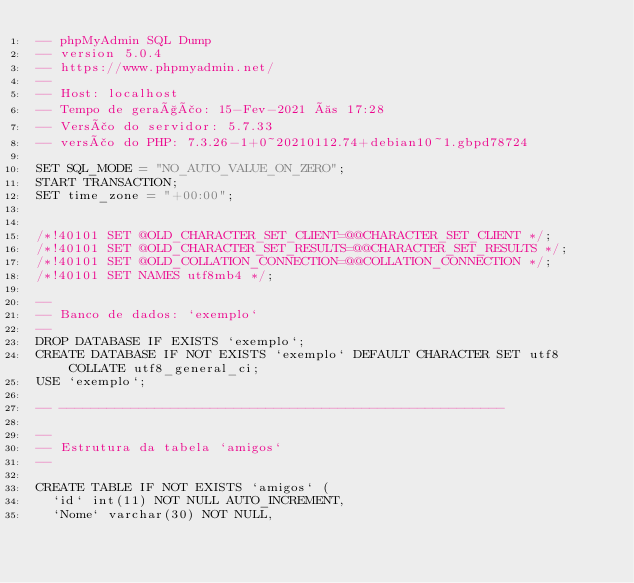<code> <loc_0><loc_0><loc_500><loc_500><_SQL_>-- phpMyAdmin SQL Dump
-- version 5.0.4
-- https://www.phpmyadmin.net/
--
-- Host: localhost
-- Tempo de geração: 15-Fev-2021 às 17:28
-- Versão do servidor: 5.7.33
-- versão do PHP: 7.3.26-1+0~20210112.74+debian10~1.gbpd78724

SET SQL_MODE = "NO_AUTO_VALUE_ON_ZERO";
START TRANSACTION;
SET time_zone = "+00:00";


/*!40101 SET @OLD_CHARACTER_SET_CLIENT=@@CHARACTER_SET_CLIENT */;
/*!40101 SET @OLD_CHARACTER_SET_RESULTS=@@CHARACTER_SET_RESULTS */;
/*!40101 SET @OLD_COLLATION_CONNECTION=@@COLLATION_CONNECTION */;
/*!40101 SET NAMES utf8mb4 */;

--
-- Banco de dados: `exemplo`
--
DROP DATABASE IF EXISTS `exemplo`;
CREATE DATABASE IF NOT EXISTS `exemplo` DEFAULT CHARACTER SET utf8 COLLATE utf8_general_ci;
USE `exemplo`;

-- --------------------------------------------------------

--
-- Estrutura da tabela `amigos`
--

CREATE TABLE IF NOT EXISTS `amigos` (
  `id` int(11) NOT NULL AUTO_INCREMENT,
  `Nome` varchar(30) NOT NULL,</code> 